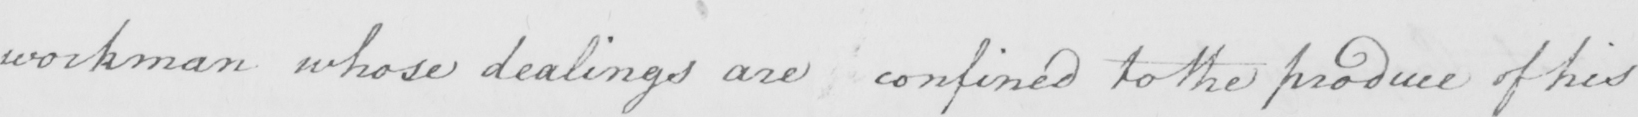Please provide the text content of this handwritten line. workman whose dealings are confined to the produce of his 